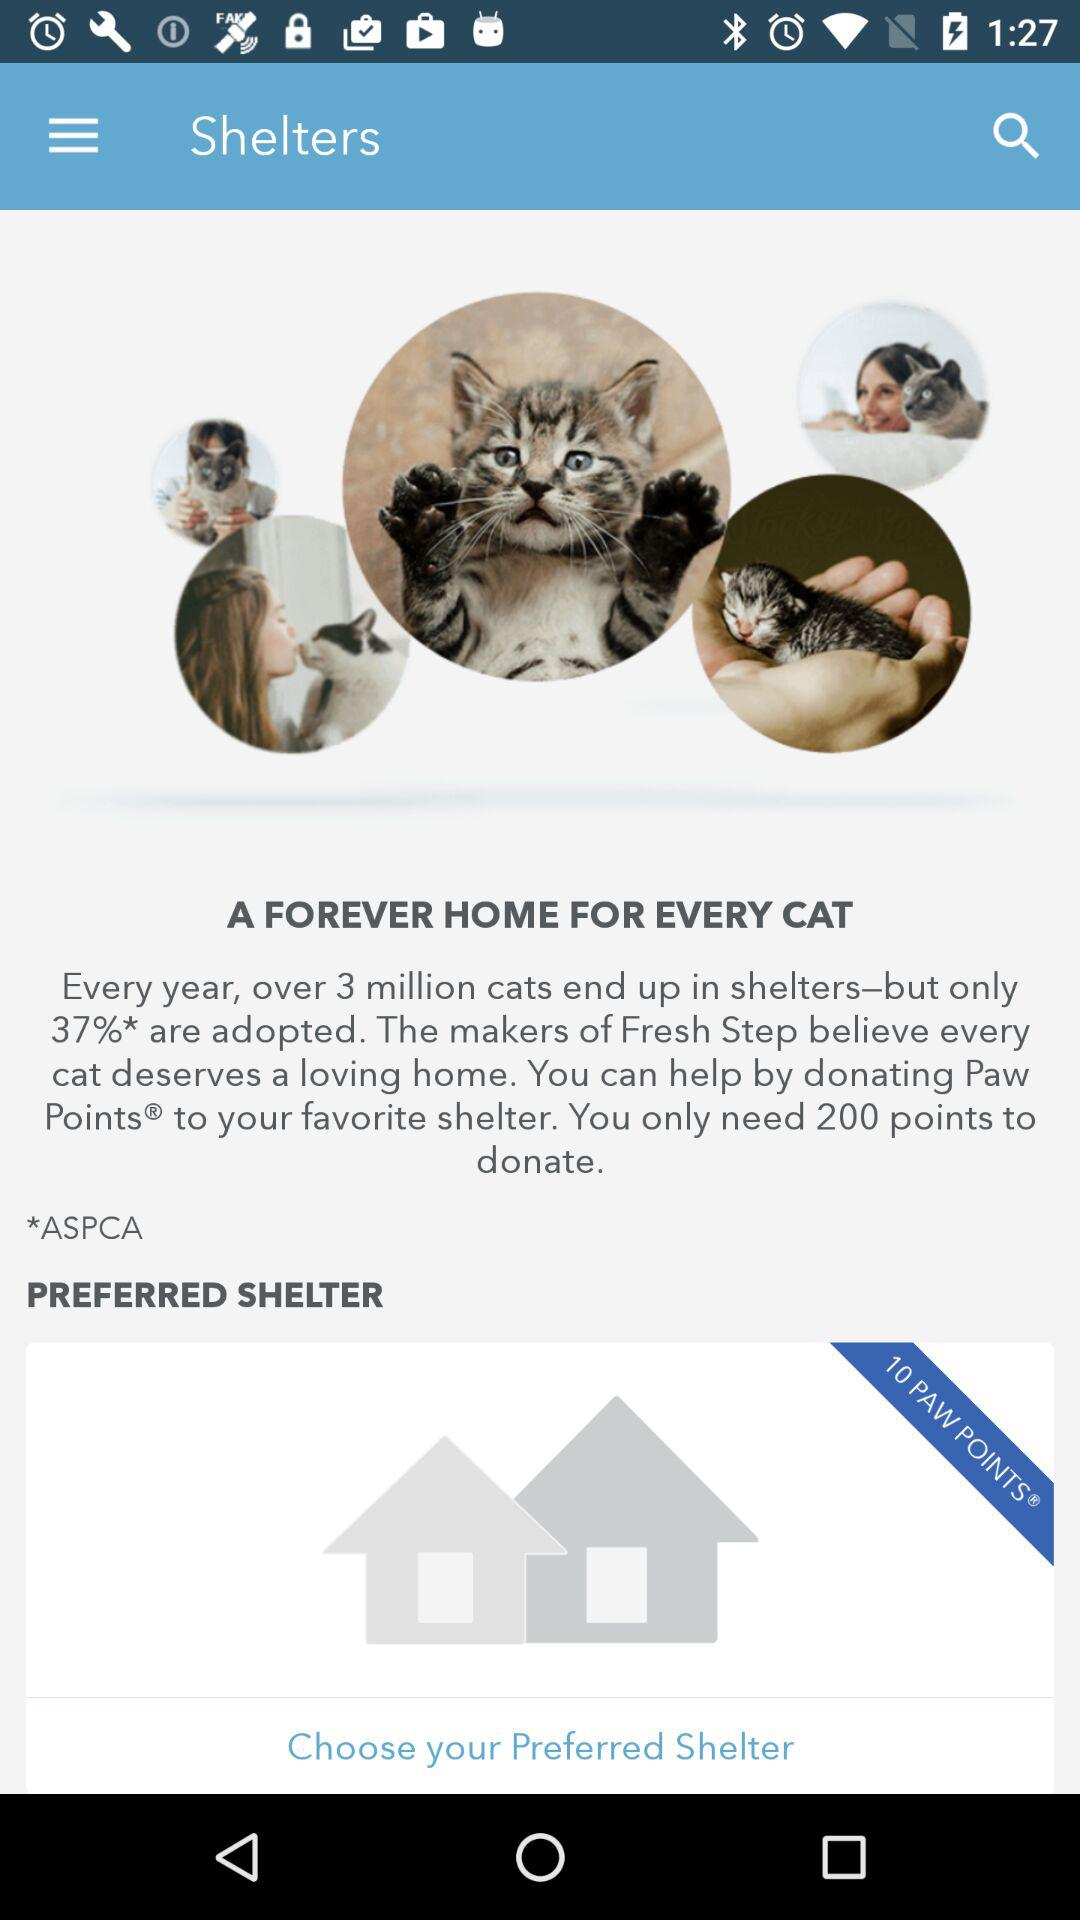How many cats are adopted every year? There are 37% of cats adopted every year. 